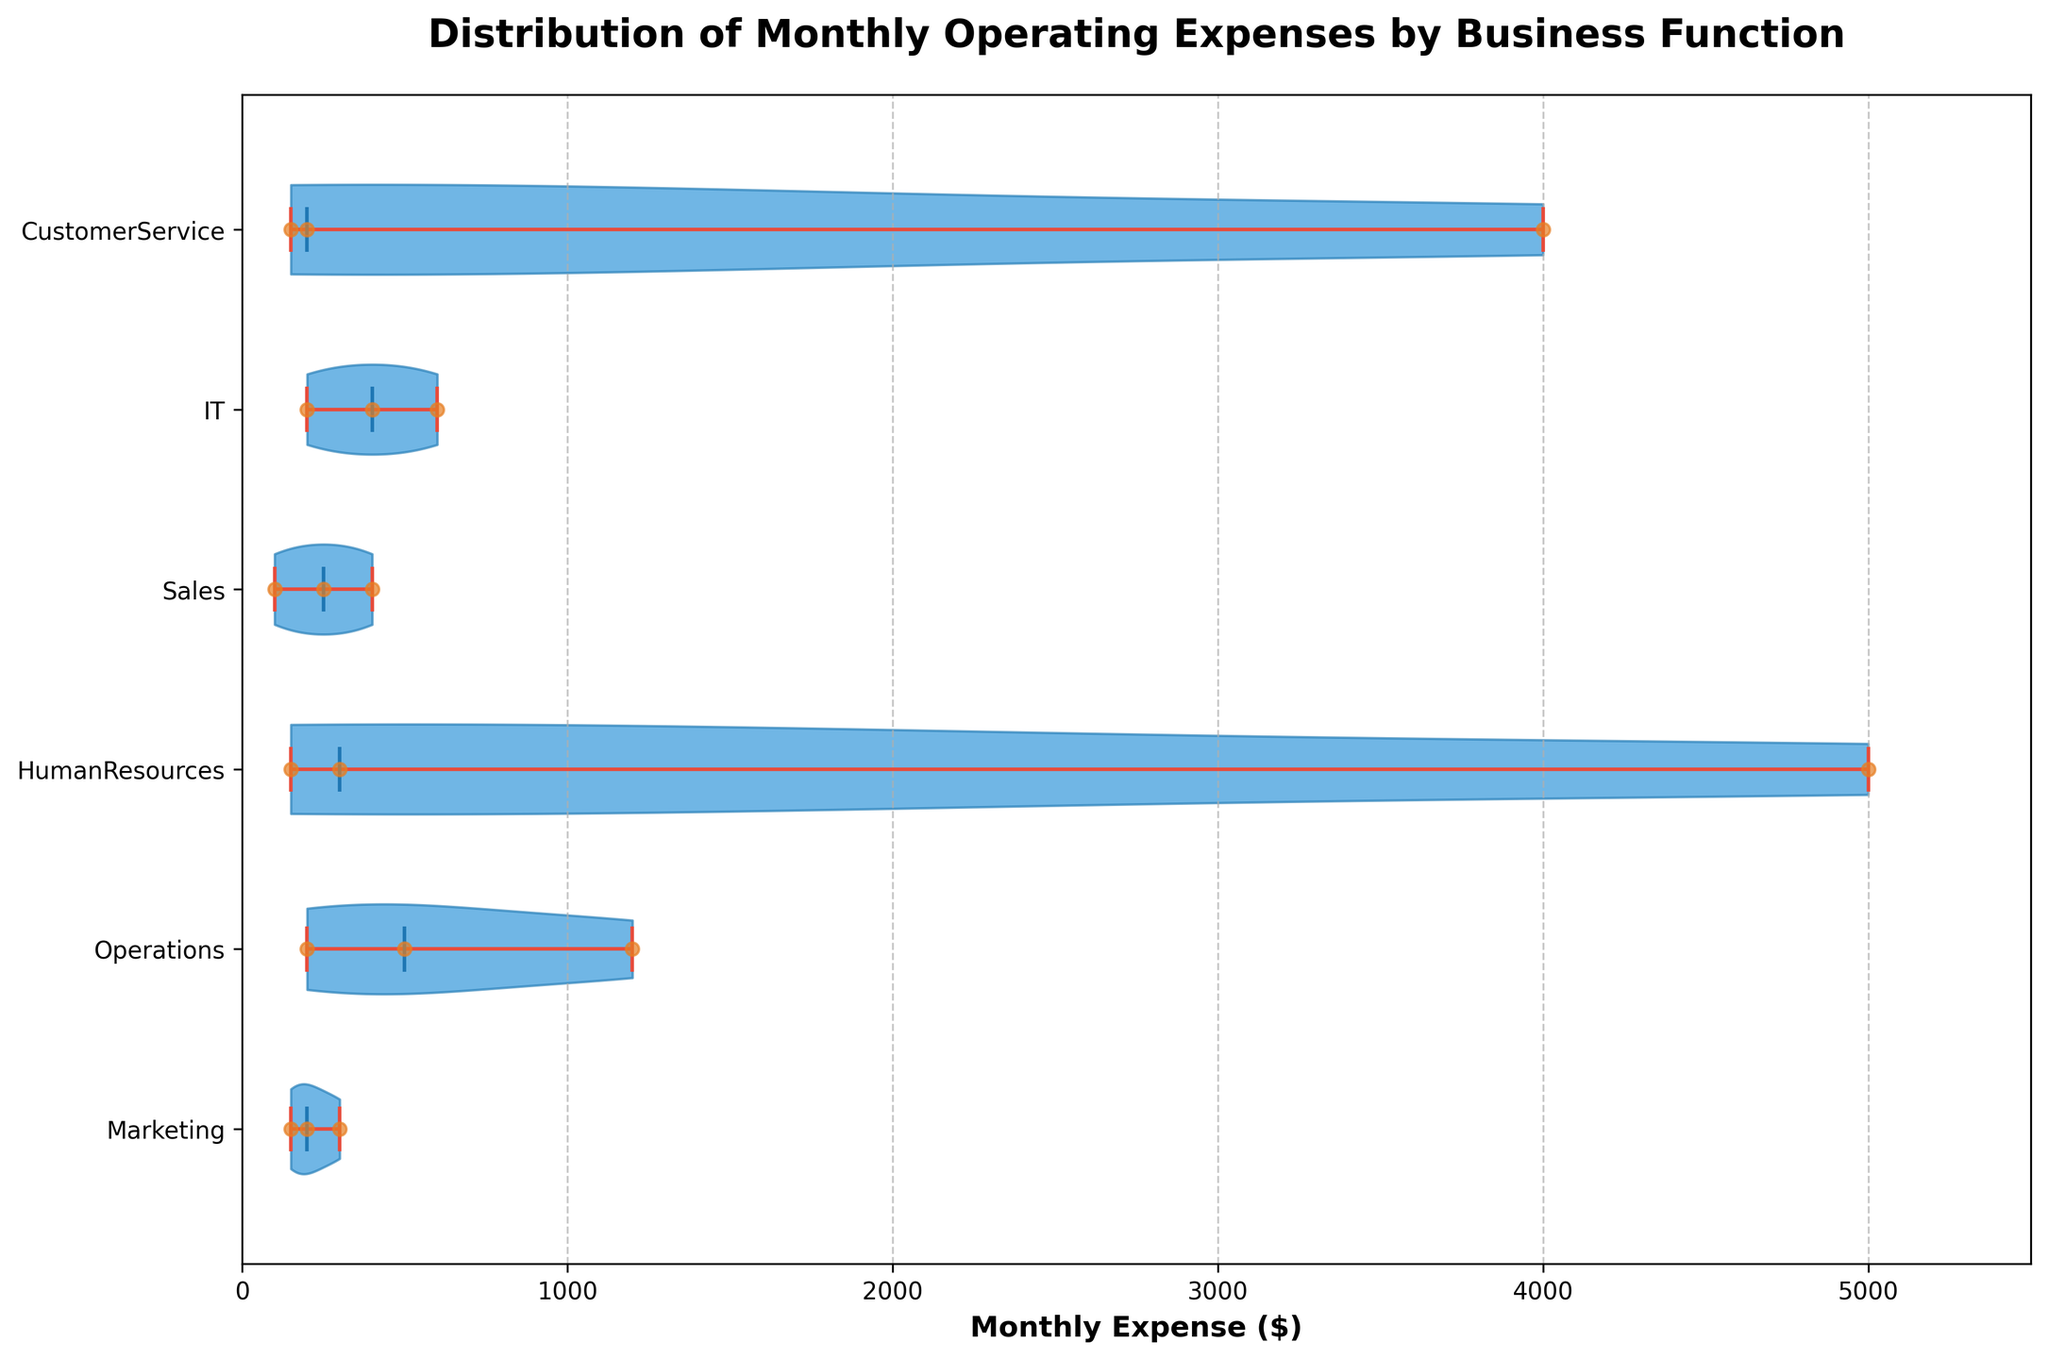What is the title of the figure? The title is located at the top of the figure and describes what the visualization represents. In this case, it reads "Distribution of Monthly Operating Expenses by Business Function".
Answer: Distribution of Monthly Operating Expenses by Business Function What is the x-axis label? The x-axis label is located along the horizontal axis and it helps to understand what metric is being measured. Here, it says "Monthly Expense ($)".
Answer: Monthly Expense ($) Which business function has the highest median monthly expense? The figure uses horizontal violin plots with a bold line indicating the median value. The business function with the median line positioned farthest to the right on the x-axis demonstrates the highest median monthly expense. In this case, it's "Human Resources".
Answer: Human Resources Which color is used for the individual data points? Data points are shown as small dots in the chart. In this figure, these dots are orange.
Answer: Orange How many business functions are represented in the chart? The y-axis contains labels for each unique business function. Counting these labels gives the total number of business functions. Here, there are 6 labels.
Answer: 6 Which two business functions have the smallest spread in their monthly expenses distribution? The spread of a violin plot indicates the range of data. The business functions with the narrowest violin shapes have the smallest spread. In this case, "Marketing" and "Customer Service" have the smallest spreads.
Answer: Marketing and Customer Service What is the maximum monthly expense value displayed on the x-axis? The maximum value on the x-axis gives an idea of the range of monthly expenses. Here, it is around $5500.
Answer: $5500 Which business function has the most variance in its monthly expense distribution? Variance can be visually estimated by looking at the width of the violin plot. A wider shape indicates higher variance. "Human Resources" has the widest violin, indicating the most variance.
Answer: Human Resources Are the means or medians shown in the figure? This figure shows the medians for each business function by the presence of a thick line in the middle of each violin plot. Means are not displayed.
Answer: Medians What is the color of the violin plots' interior? The interior of the violin plots have a specific color, which is a shade of blue.
Answer: Blue 